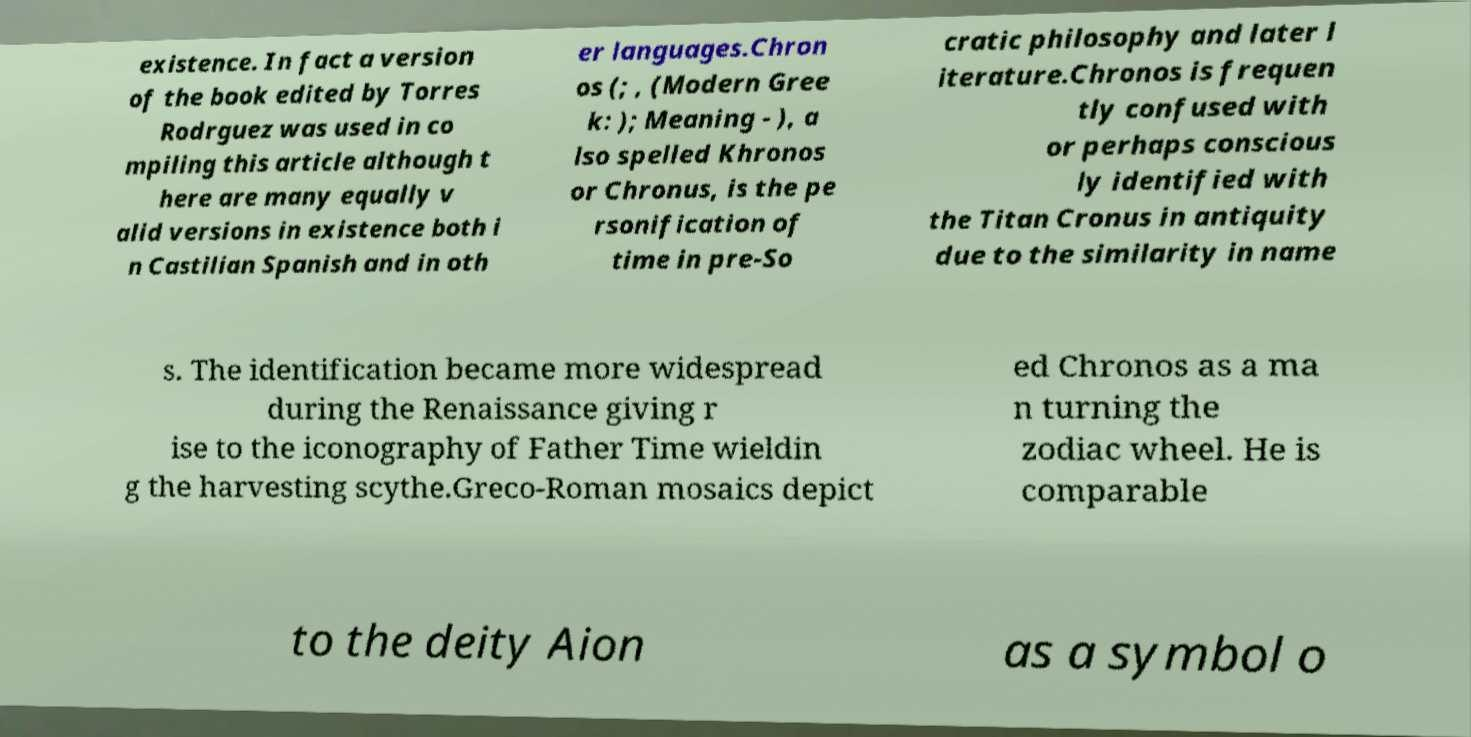Could you extract and type out the text from this image? existence. In fact a version of the book edited by Torres Rodrguez was used in co mpiling this article although t here are many equally v alid versions in existence both i n Castilian Spanish and in oth er languages.Chron os (; , (Modern Gree k: ); Meaning - ), a lso spelled Khronos or Chronus, is the pe rsonification of time in pre-So cratic philosophy and later l iterature.Chronos is frequen tly confused with or perhaps conscious ly identified with the Titan Cronus in antiquity due to the similarity in name s. The identification became more widespread during the Renaissance giving r ise to the iconography of Father Time wieldin g the harvesting scythe.Greco-Roman mosaics depict ed Chronos as a ma n turning the zodiac wheel. He is comparable to the deity Aion as a symbol o 